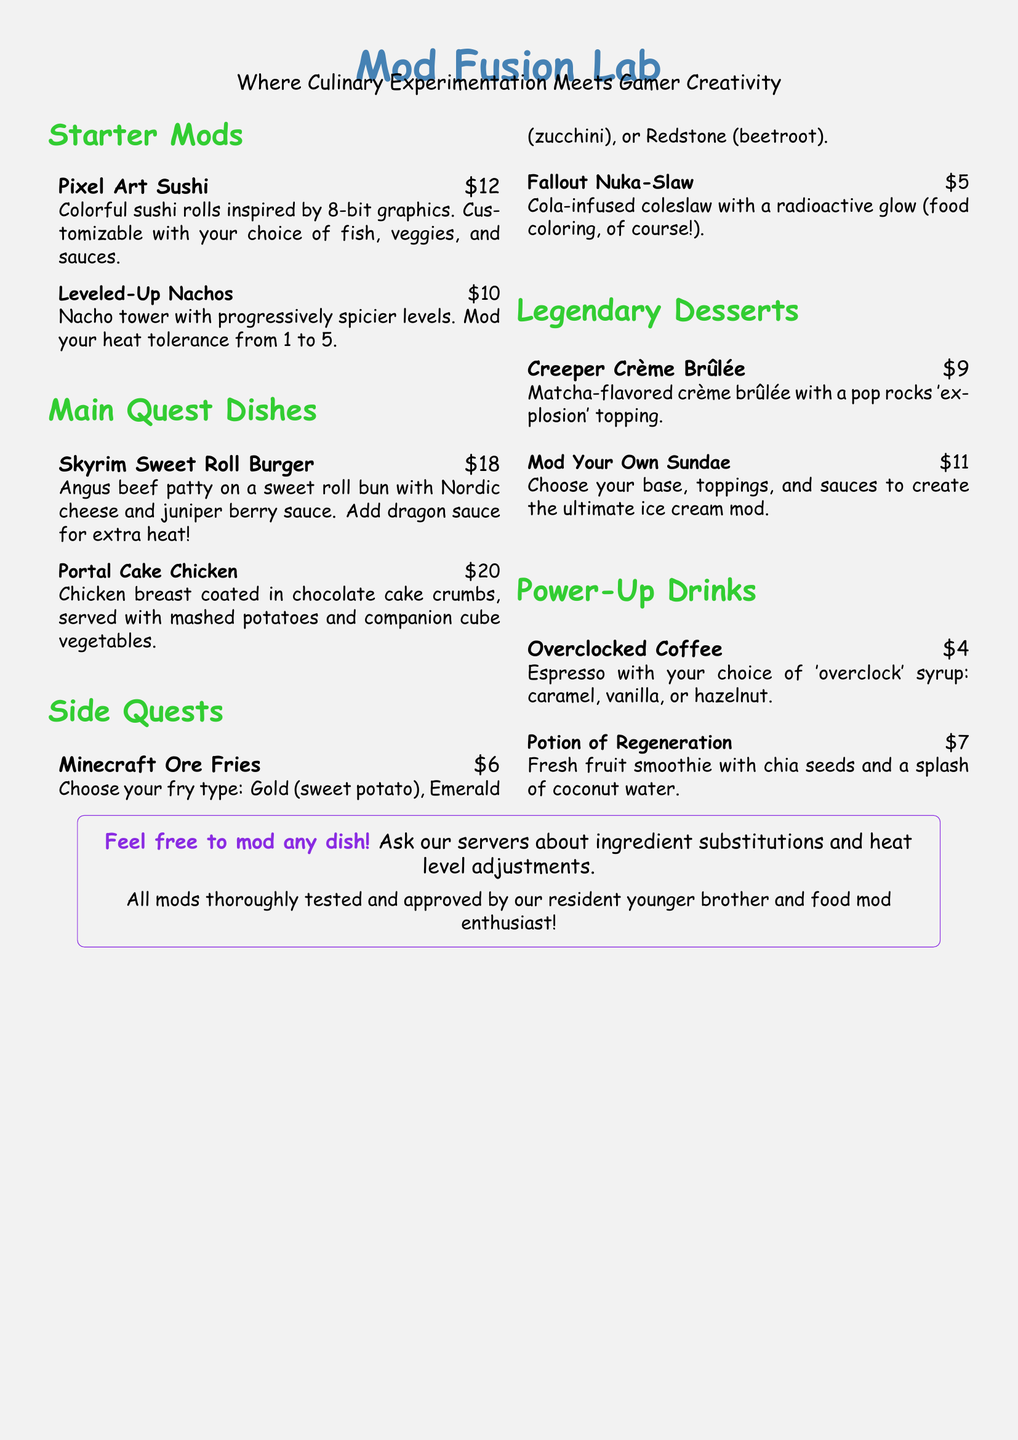What is the name of the restaurant? The name of the restaurant is clearly stated at the top of the menu.
Answer: Mod Fusion Lab What is the price of Pixel Art Sushi? The price is mentioned alongside the item in the menu.
Answer: $12 How many levels of heat are available for the Leveled-Up Nachos? The menu states that the Nachos have progressively spicier levels.
Answer: 5 What type of dessert can you create with a modifiable option? The menu specifies a customizable dessert option.
Answer: Sundae What type of fries can you choose from in Minecraft Ore Fries? The menu lists the types of fries available.
Answer: Gold, Emerald, Redstone What is included in the Power-Up Drinks section? The menu lists drink options categorized under Power-Up Drinks.
Answer: Overclocked Coffee, Potion of Regeneration What type of meat is used in the Skyrim Sweet Roll Burger? The menu lists the type of meat used in that burger dish.
Answer: Angus beef patty Is there a note about ingredient substitutions? The menu contains a note addressing substitutions.
Answer: Yes What is the unique topping on the Creeper Crème Brûlée? The menu mentions the specific topping that is unusual for this dessert.
Answer: Pop rocks 'explosion' topping What color is the glow in the Fallout Nuka-Slaw? The menu describes the visual effect of the slaw's glow.
Answer: Radioactive glow 